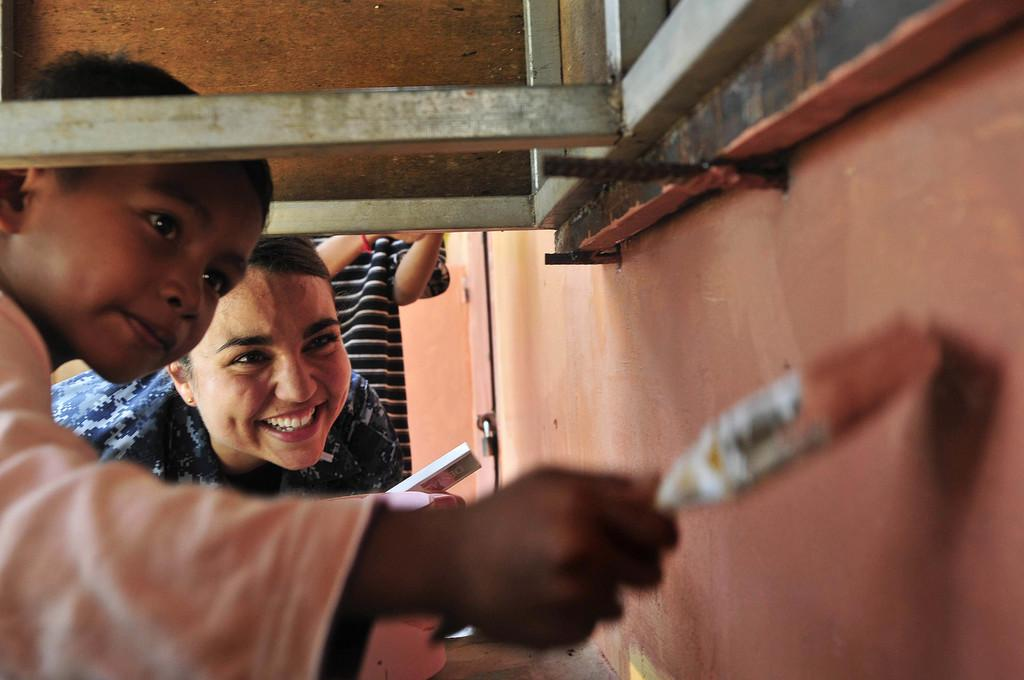What is the main subject in the foreground of the image? There is a boy in the foreground of the image. What is the boy doing in the image? The boy is painting on a wall. What tool is the boy using for painting? The boy is holding a brush. What can be seen at the top of the image? There is an object at the top of the image. How many people are in the background of the image? There are two people in the background of the image. What type of food is being prepared by the boy in the image? There is no food preparation visible in the image; the boy is painting on a wall. Can you tell me how many astronauts are present in the image? There are no astronauts or any reference to space in the image. 